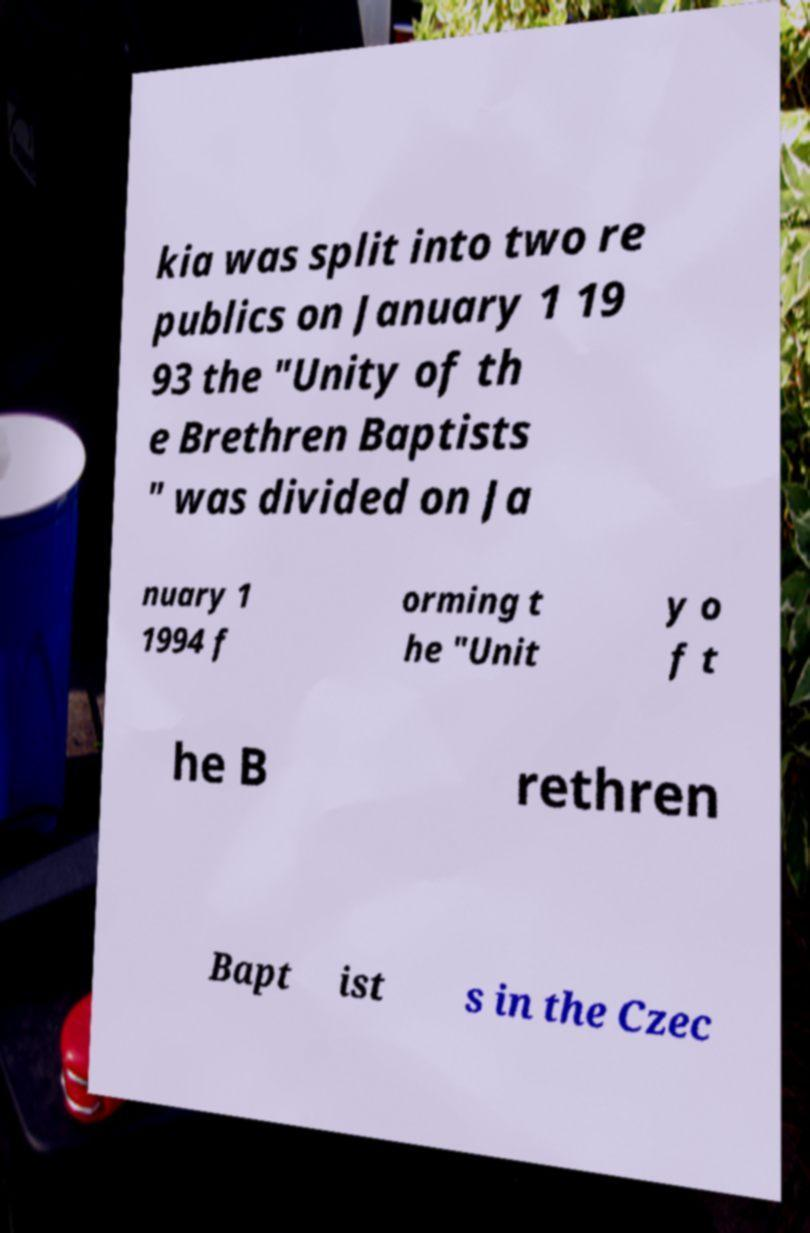For documentation purposes, I need the text within this image transcribed. Could you provide that? kia was split into two re publics on January 1 19 93 the "Unity of th e Brethren Baptists " was divided on Ja nuary 1 1994 f orming t he "Unit y o f t he B rethren Bapt ist s in the Czec 